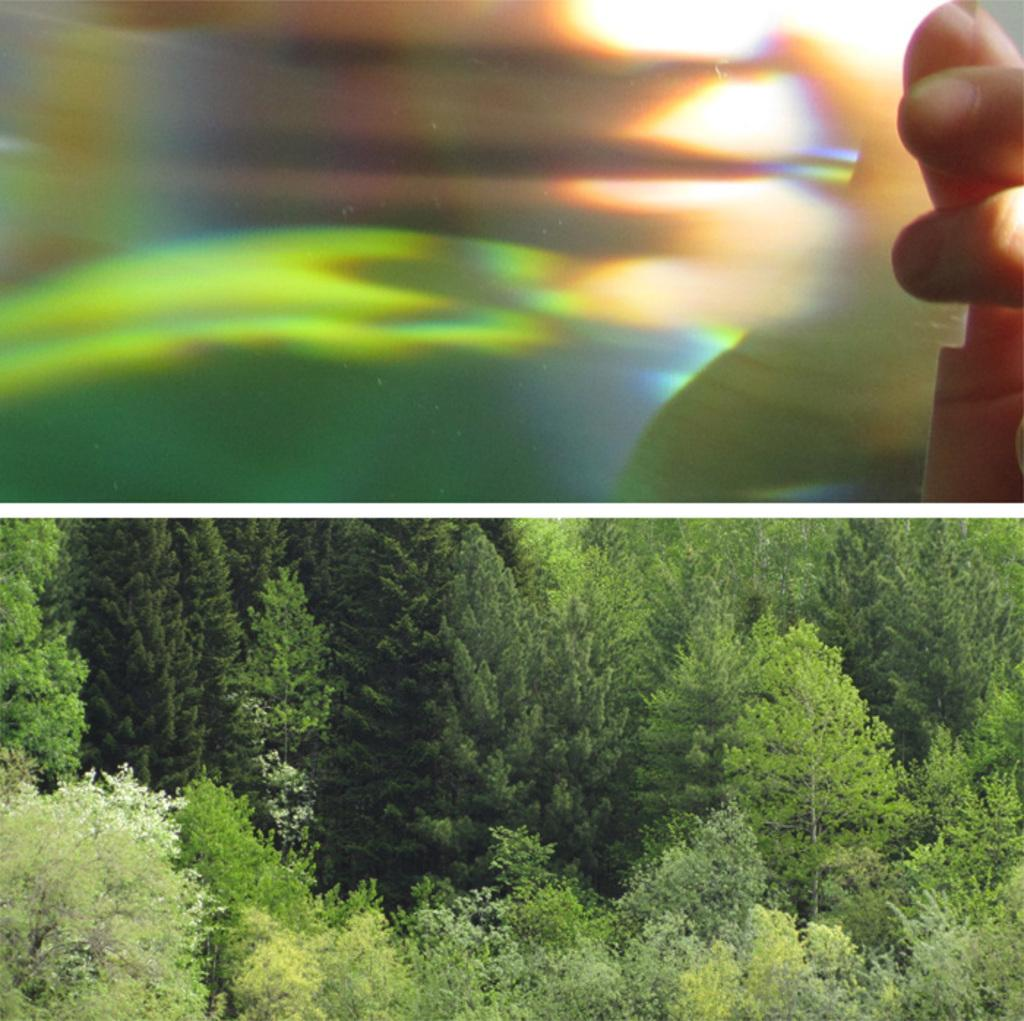What is being held by the person's hand in the first image? Unfortunately, the specific object being held cannot be determined from the given facts. What can be seen in the second image? In the second image, there are trees. How many necks can be seen in the first image? There are no necks visible in the first image. Can you describe the jumping motion of the trees in the second image? There is no jumping motion in the second image, as trees do not have the ability to jump. 